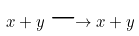<formula> <loc_0><loc_0><loc_500><loc_500>x + y \longrightarrow x + y</formula> 